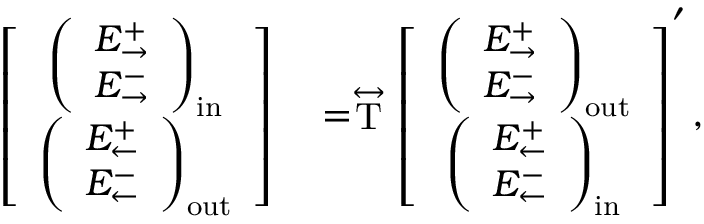<formula> <loc_0><loc_0><loc_500><loc_500>\begin{array} { r l } { \left [ \begin{array} { c } { \left ( \begin{array} { c } { E _ { \rightarrow } ^ { + } } \\ { E _ { \rightarrow } ^ { - } } \end{array} \right ) _ { i n } } \\ { \left ( \begin{array} { c } { E _ { \leftarrow } ^ { + } } \\ { E _ { \leftarrow } ^ { - } } \end{array} \right ) _ { o u t } } \end{array} \right ] } & = \stackrel { \leftrightarrow } { T } \left [ \begin{array} { c } { \left ( \begin{array} { c } { E _ { \rightarrow } ^ { + } } \\ { E _ { \rightarrow } ^ { - } } \end{array} \right ) _ { o u t } } \\ { \left ( \begin{array} { c } { E _ { \leftarrow } ^ { + } } \\ { E _ { \leftarrow } ^ { - } } \end{array} \right ) _ { i n } } \end{array} \right ] ^ { \prime } , } \end{array}</formula> 